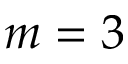Convert formula to latex. <formula><loc_0><loc_0><loc_500><loc_500>m = 3</formula> 